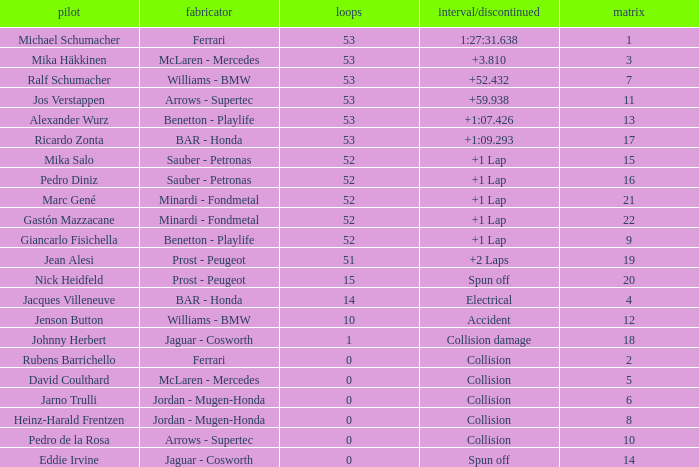What is the grid number with less than 52 laps and a Time/Retired of collision, and a Constructor of arrows - supertec? 1.0. 